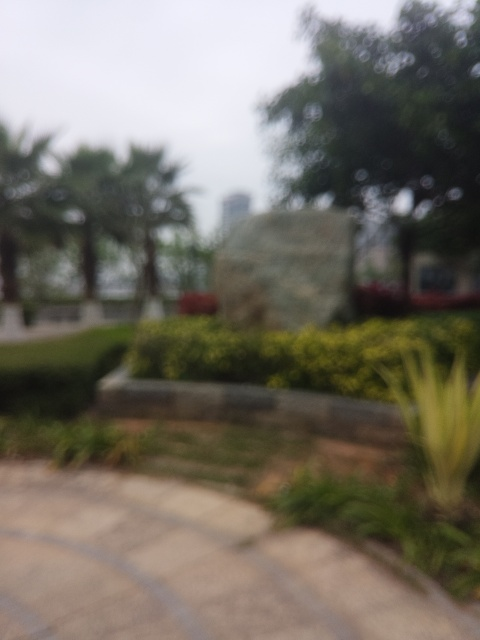Can you describe the setting of this image? Based on the blurred image, it appears to be an outdoor setting, likely a park or garden. There seems to be a mix of vegetation, with trees and shrubs, and a hardscape area that might be a walkway or paved path. A large, indistinct object in the mid-ground could be a monument or sign, and the overall ambiance suggests a tranquil public space meant for leisure. 